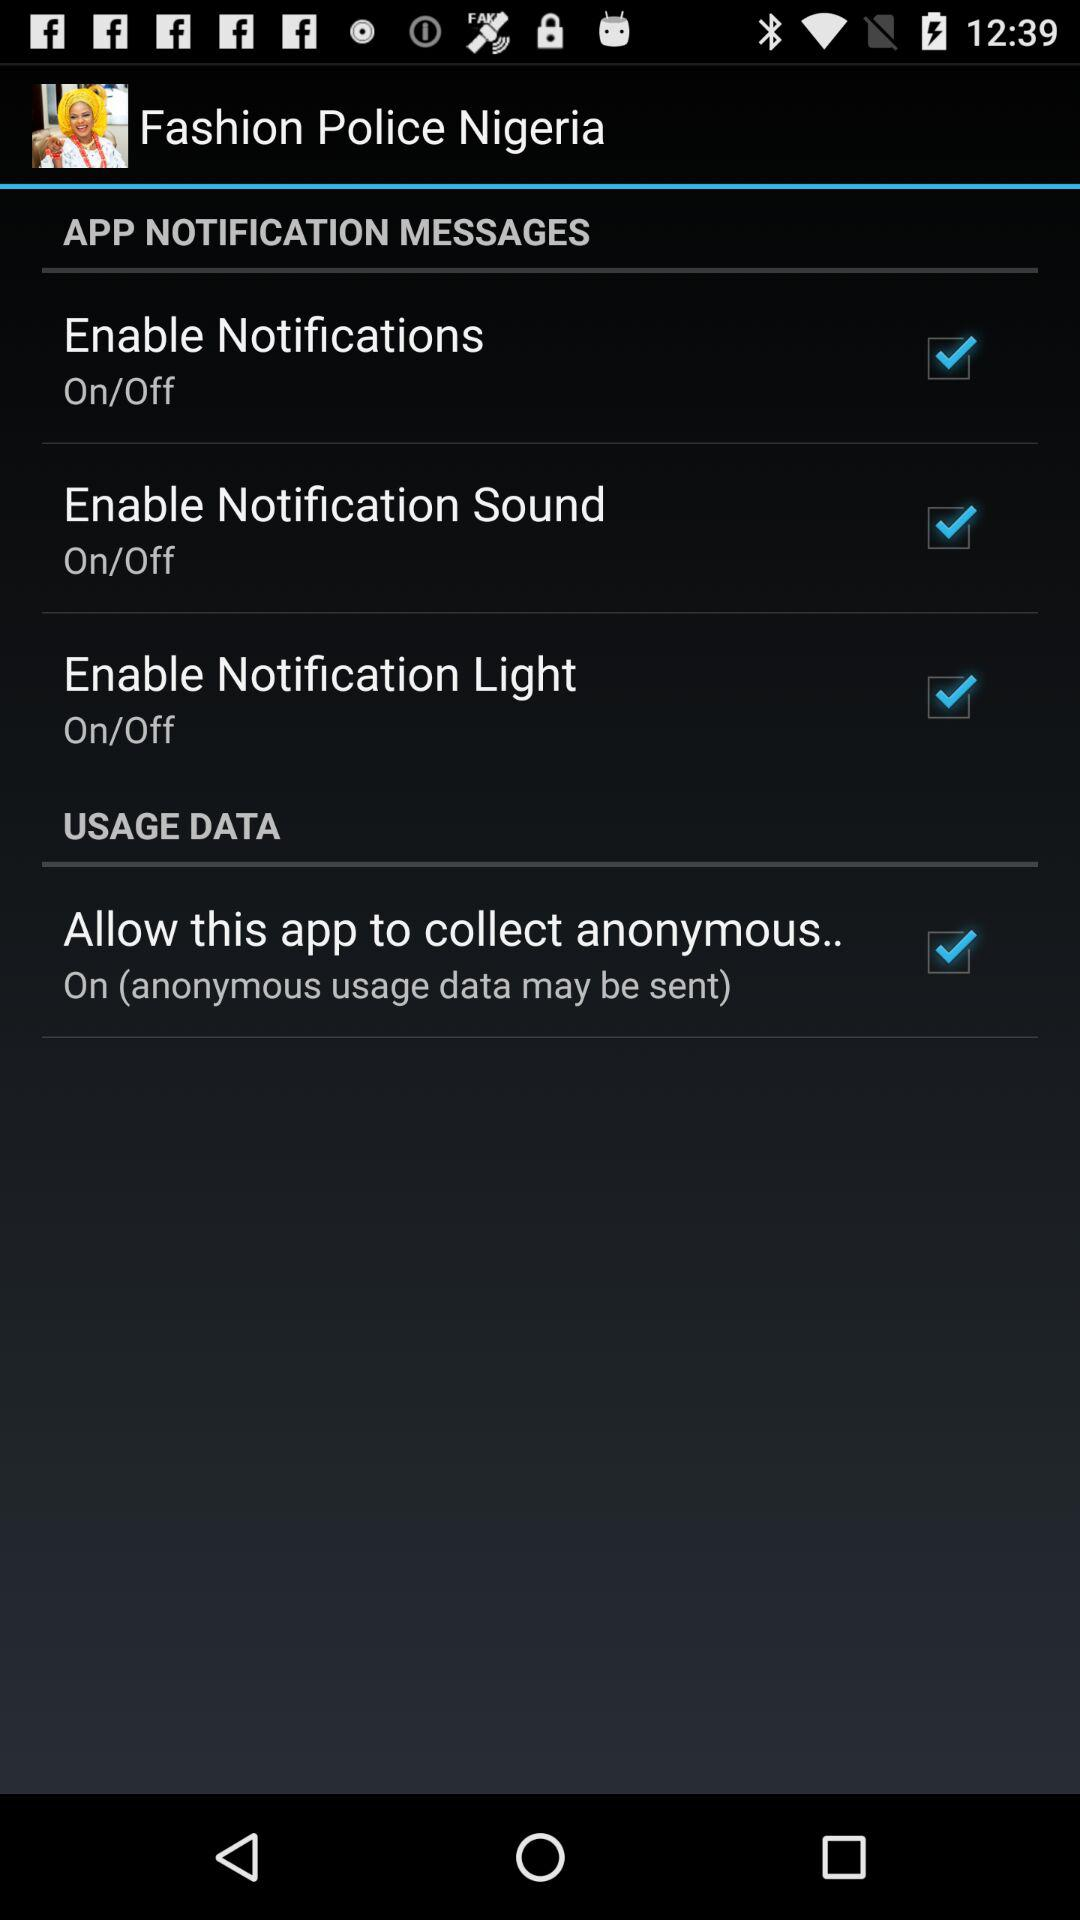What is the current status of "Allow this app to collect anonymous.."? The current status of "Allow this app to collect anonymous.." is "on". 